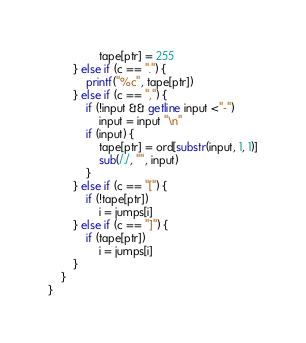<code> <loc_0><loc_0><loc_500><loc_500><_Awk_>                tape[ptr] = 255
        } else if (c == ".") {
            printf("%c", tape[ptr])
        } else if (c == ",") {
            if (!input && getline input <"-")
                input = input "\n"
            if (input) {
                tape[ptr] = ord[substr(input, 1, 1)]
                sub(/./, "", input)
            }
        } else if (c == "[") {
            if (!tape[ptr])
                i = jumps[i]
        } else if (c == "]") {
            if (tape[ptr])
                i = jumps[i]
        }
    }
}
</code> 